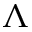<formula> <loc_0><loc_0><loc_500><loc_500>\Lambda</formula> 